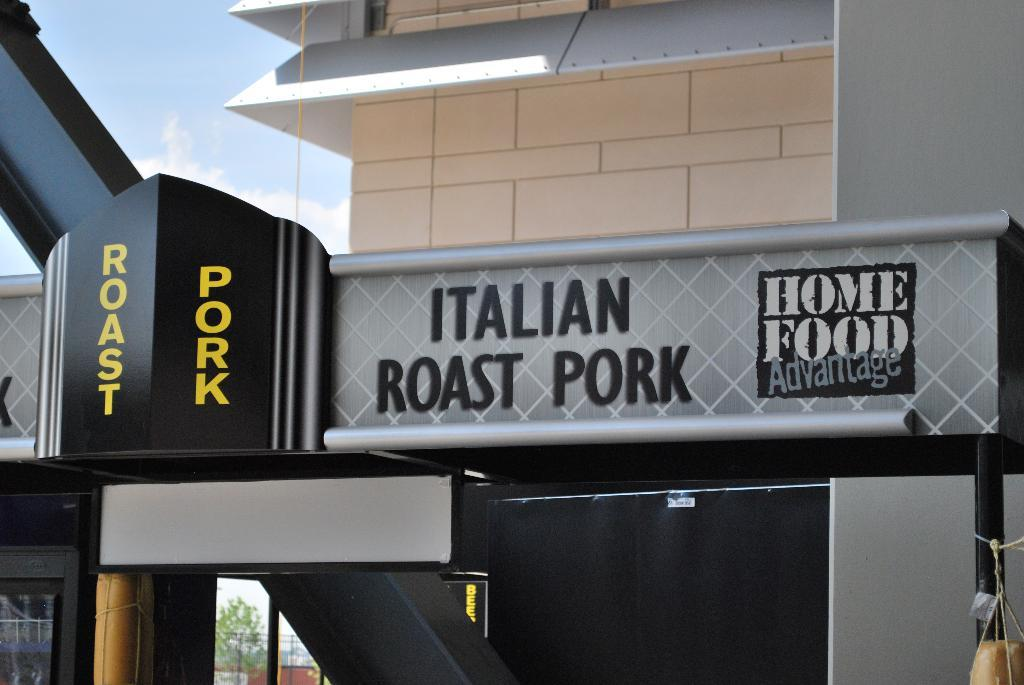What type of structure is in the image? There is a building in the image. What feature is present in front of the building? The building has an arch in front of it. What might the building be used for? The building appears to be a restaurant. What is visible at the top of the image? The sky is visible at the top of the image. What type of behavior can be observed in the seed in the image? There is no seed present in the image, so it is not possible to observe any behavior. 